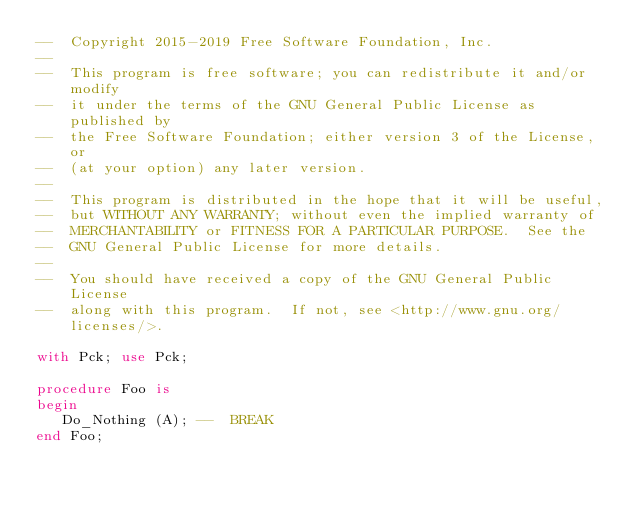Convert code to text. <code><loc_0><loc_0><loc_500><loc_500><_Ada_>--  Copyright 2015-2019 Free Software Foundation, Inc.
--
--  This program is free software; you can redistribute it and/or modify
--  it under the terms of the GNU General Public License as published by
--  the Free Software Foundation; either version 3 of the License, or
--  (at your option) any later version.
--
--  This program is distributed in the hope that it will be useful,
--  but WITHOUT ANY WARRANTY; without even the implied warranty of
--  MERCHANTABILITY or FITNESS FOR A PARTICULAR PURPOSE.  See the
--  GNU General Public License for more details.
--
--  You should have received a copy of the GNU General Public License
--  along with this program.  If not, see <http://www.gnu.org/licenses/>.

with Pck; use Pck;

procedure Foo is
begin
   Do_Nothing (A); --  BREAK
end Foo;
</code> 